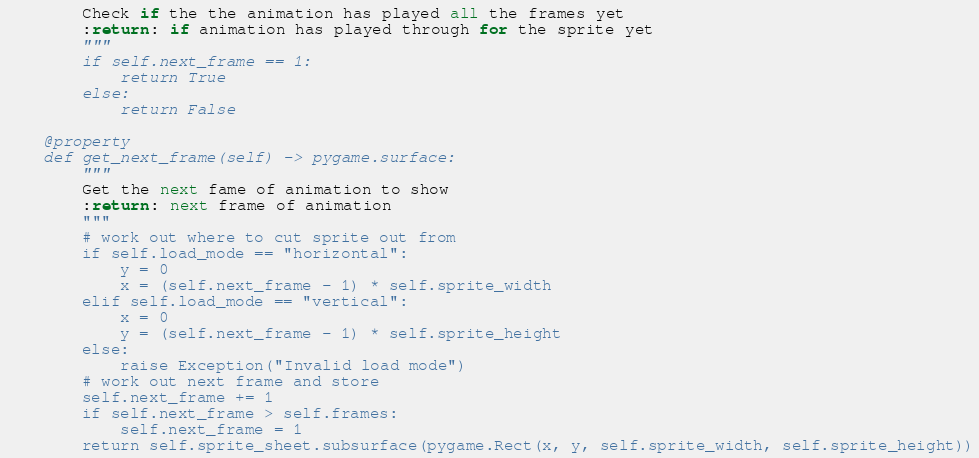Convert code to text. <code><loc_0><loc_0><loc_500><loc_500><_Python_>        Check if the the animation has played all the frames yet
        :return: if animation has played through for the sprite yet
        """
        if self.next_frame == 1:
            return True
        else:
            return False

    @property
    def get_next_frame(self) -> pygame.surface:
        """
        Get the next fame of animation to show
        :return: next frame of animation
        """
        # work out where to cut sprite out from
        if self.load_mode == "horizontal":
            y = 0
            x = (self.next_frame - 1) * self.sprite_width
        elif self.load_mode == "vertical":
            x = 0
            y = (self.next_frame - 1) * self.sprite_height
        else:
            raise Exception("Invalid load mode")
        # work out next frame and store
        self.next_frame += 1
        if self.next_frame > self.frames:
            self.next_frame = 1
        return self.sprite_sheet.subsurface(pygame.Rect(x, y, self.sprite_width, self.sprite_height))</code> 